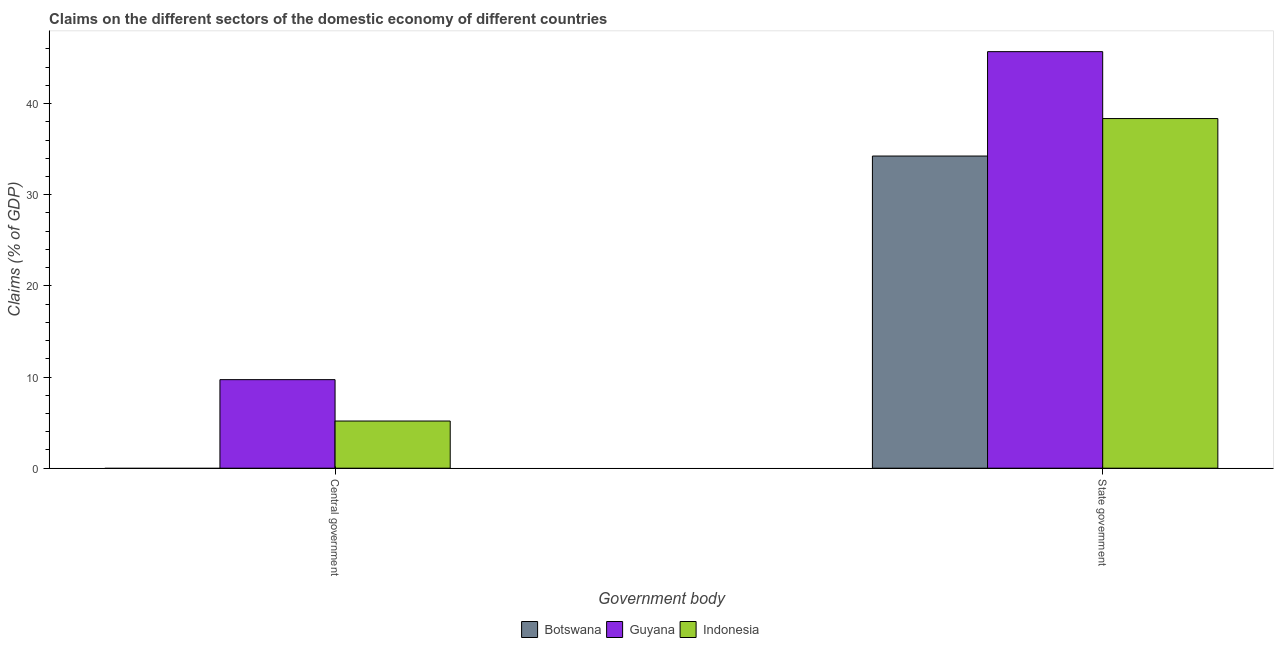How many bars are there on the 2nd tick from the left?
Your answer should be compact. 3. What is the label of the 1st group of bars from the left?
Keep it short and to the point. Central government. What is the claims on state government in Indonesia?
Your response must be concise. 38.35. Across all countries, what is the maximum claims on central government?
Ensure brevity in your answer.  9.71. Across all countries, what is the minimum claims on central government?
Offer a terse response. 0. In which country was the claims on state government maximum?
Offer a terse response. Guyana. What is the total claims on central government in the graph?
Keep it short and to the point. 14.89. What is the difference between the claims on central government in Indonesia and that in Guyana?
Make the answer very short. -4.54. What is the difference between the claims on state government in Guyana and the claims on central government in Botswana?
Provide a succinct answer. 45.69. What is the average claims on state government per country?
Your answer should be compact. 39.43. What is the difference between the claims on central government and claims on state government in Guyana?
Your response must be concise. -35.98. What is the ratio of the claims on central government in Indonesia to that in Guyana?
Offer a very short reply. 0.53. Is the claims on state government in Indonesia less than that in Botswana?
Your response must be concise. No. Are all the bars in the graph horizontal?
Offer a very short reply. No. Are the values on the major ticks of Y-axis written in scientific E-notation?
Make the answer very short. No. How many legend labels are there?
Your answer should be compact. 3. How are the legend labels stacked?
Provide a succinct answer. Horizontal. What is the title of the graph?
Make the answer very short. Claims on the different sectors of the domestic economy of different countries. Does "French Polynesia" appear as one of the legend labels in the graph?
Keep it short and to the point. No. What is the label or title of the X-axis?
Offer a very short reply. Government body. What is the label or title of the Y-axis?
Your answer should be compact. Claims (% of GDP). What is the Claims (% of GDP) of Guyana in Central government?
Offer a terse response. 9.71. What is the Claims (% of GDP) in Indonesia in Central government?
Give a very brief answer. 5.17. What is the Claims (% of GDP) of Botswana in State government?
Your answer should be compact. 34.24. What is the Claims (% of GDP) of Guyana in State government?
Offer a terse response. 45.69. What is the Claims (% of GDP) of Indonesia in State government?
Make the answer very short. 38.35. Across all Government body, what is the maximum Claims (% of GDP) of Botswana?
Ensure brevity in your answer.  34.24. Across all Government body, what is the maximum Claims (% of GDP) in Guyana?
Provide a short and direct response. 45.69. Across all Government body, what is the maximum Claims (% of GDP) in Indonesia?
Your answer should be compact. 38.35. Across all Government body, what is the minimum Claims (% of GDP) of Guyana?
Keep it short and to the point. 9.71. Across all Government body, what is the minimum Claims (% of GDP) of Indonesia?
Offer a terse response. 5.17. What is the total Claims (% of GDP) of Botswana in the graph?
Give a very brief answer. 34.24. What is the total Claims (% of GDP) in Guyana in the graph?
Ensure brevity in your answer.  55.41. What is the total Claims (% of GDP) in Indonesia in the graph?
Your answer should be very brief. 43.53. What is the difference between the Claims (% of GDP) of Guyana in Central government and that in State government?
Offer a terse response. -35.98. What is the difference between the Claims (% of GDP) in Indonesia in Central government and that in State government?
Ensure brevity in your answer.  -33.18. What is the difference between the Claims (% of GDP) in Guyana in Central government and the Claims (% of GDP) in Indonesia in State government?
Give a very brief answer. -28.64. What is the average Claims (% of GDP) of Botswana per Government body?
Make the answer very short. 17.12. What is the average Claims (% of GDP) of Guyana per Government body?
Offer a very short reply. 27.7. What is the average Claims (% of GDP) in Indonesia per Government body?
Ensure brevity in your answer.  21.76. What is the difference between the Claims (% of GDP) in Guyana and Claims (% of GDP) in Indonesia in Central government?
Provide a short and direct response. 4.54. What is the difference between the Claims (% of GDP) of Botswana and Claims (% of GDP) of Guyana in State government?
Your answer should be very brief. -11.45. What is the difference between the Claims (% of GDP) of Botswana and Claims (% of GDP) of Indonesia in State government?
Keep it short and to the point. -4.11. What is the difference between the Claims (% of GDP) in Guyana and Claims (% of GDP) in Indonesia in State government?
Provide a short and direct response. 7.34. What is the ratio of the Claims (% of GDP) of Guyana in Central government to that in State government?
Offer a terse response. 0.21. What is the ratio of the Claims (% of GDP) in Indonesia in Central government to that in State government?
Your answer should be compact. 0.13. What is the difference between the highest and the second highest Claims (% of GDP) of Guyana?
Your answer should be compact. 35.98. What is the difference between the highest and the second highest Claims (% of GDP) in Indonesia?
Provide a succinct answer. 33.18. What is the difference between the highest and the lowest Claims (% of GDP) of Botswana?
Your response must be concise. 34.24. What is the difference between the highest and the lowest Claims (% of GDP) of Guyana?
Provide a succinct answer. 35.98. What is the difference between the highest and the lowest Claims (% of GDP) in Indonesia?
Offer a terse response. 33.18. 